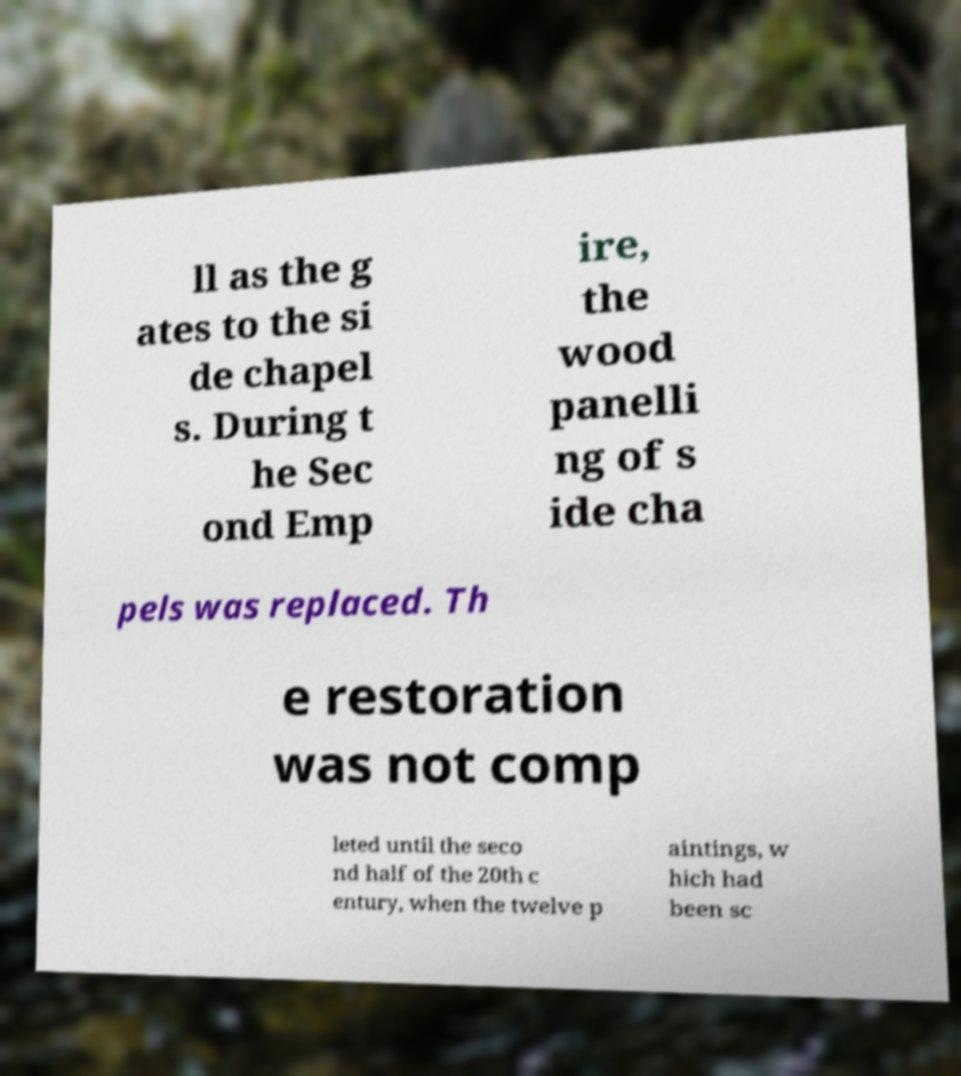There's text embedded in this image that I need extracted. Can you transcribe it verbatim? ll as the g ates to the si de chapel s. During t he Sec ond Emp ire, the wood panelli ng of s ide cha pels was replaced. Th e restoration was not comp leted until the seco nd half of the 20th c entury, when the twelve p aintings, w hich had been sc 